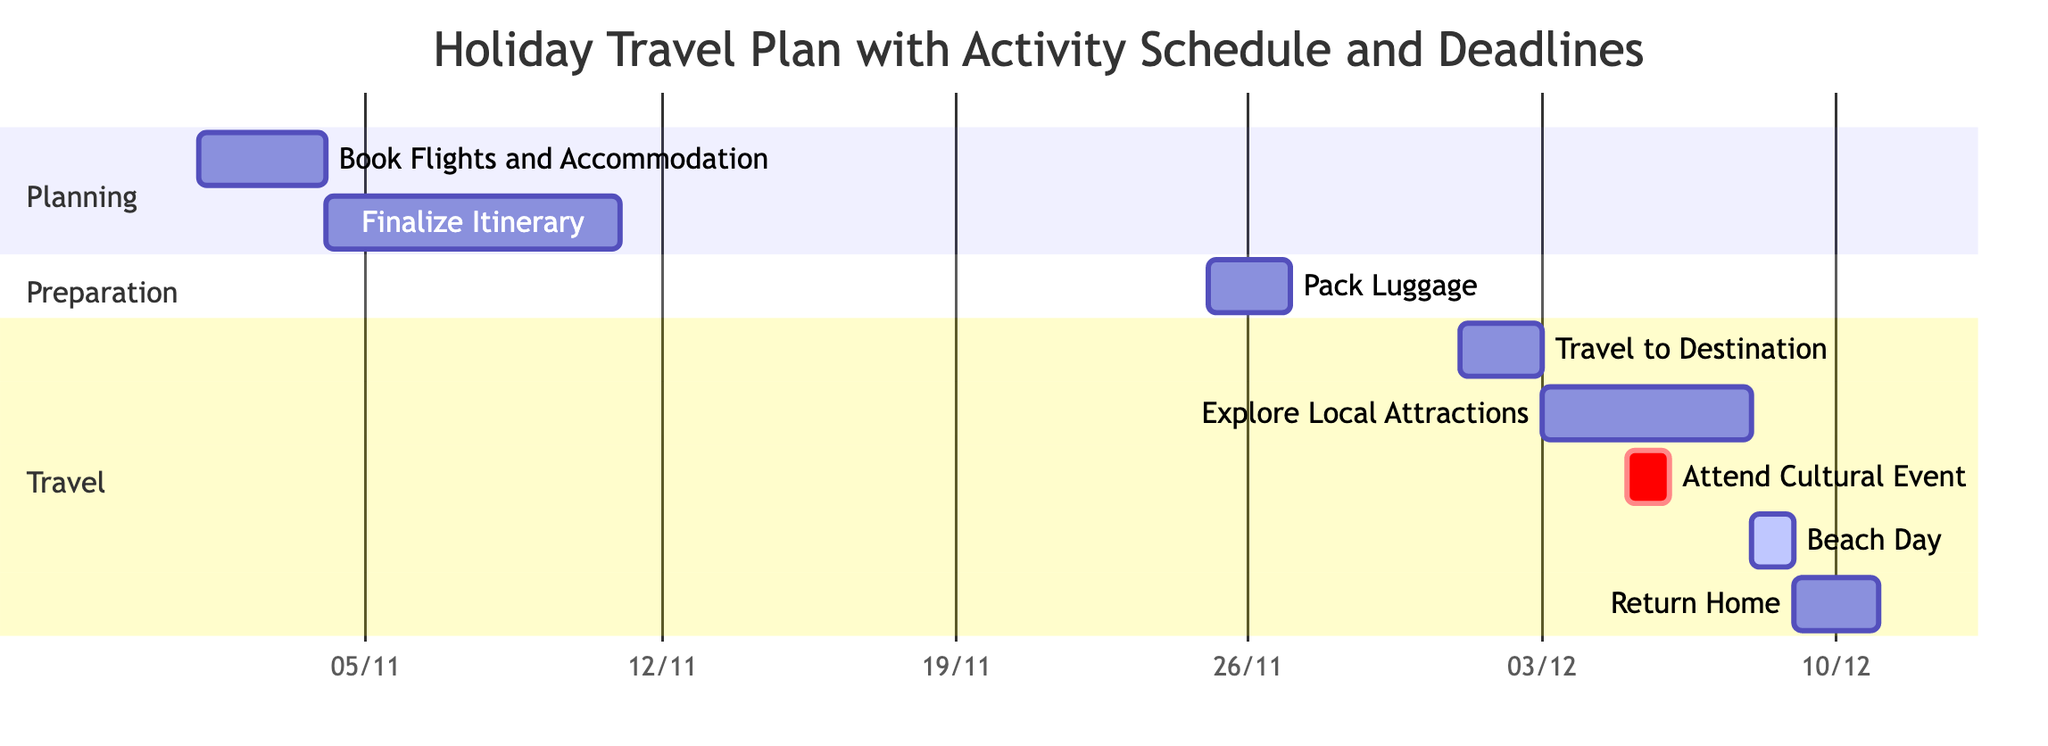what is the duration of the "Pack Luggage" task? The "Pack Luggage" task starts on November 25, 2023, and ends on November 26, 2023. This gives a total duration of 2 days (from start to end date inclusive).
Answer: 2 days which task occurs immediately after "Finalize Itinerary"? The "Finalize Itinerary" task ends on November 10, 2023, and the next task in the sequence is "Pack Luggage," which starts on November 25, 2023. Therefore, "Pack Luggage" occurs immediately after "Finalize Itinerary."
Answer: Pack Luggage how many tasks are included in the "Travel" section? The "Travel" section consists of five defined tasks: "Travel to Destination," "Explore Local Attractions," "Attend Cultural Event," "Beach Day," and "Return Home." Counting these, we find that there are five tasks in the "Travel" section.
Answer: 5 when is the "Beach Day" scheduled? The "Beach Day" task is scheduled for December 8, 2023, as indicated in the Gantt chart under the "Travel" section.
Answer: December 8, 2023 what is the end date of the "Attend Cultural Event"? The task "Attend Cultural Event" is marked with a specific duration of one day and is scheduled for December 5, 2023. Therefore, the end date is the same as the start date.
Answer: December 5, 2023 how many days are there between "Travel to Destination" and "Explore Local Attractions"? "Travel to Destination" ends on December 2, 2023, and "Explore Local Attractions" starts on December 3, 2023. Thus, there is 1 day between these two tasks.
Answer: 1 day which task overlaps with "Explore Local Attractions"? The "Attend Cultural Event" task overlaps with "Explore Local Attractions" as it occurs on December 5, 2023, which is within the duration of "Explore Local Attractions," which runs from December 3 to December 7, 2023.
Answer: Attend Cultural Event what is the total duration of the entire holiday travel plan? The entire holiday travel plan starts with the first task "Book Flights and Accommodation" on November 1, 2023, and ends with "Return Home" on December 10, 2023. Therefore, the total duration from the start to the end is 40 days.
Answer: 40 days 